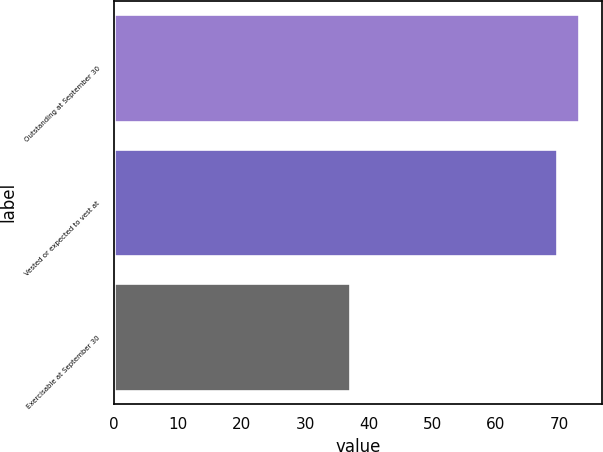Convert chart. <chart><loc_0><loc_0><loc_500><loc_500><bar_chart><fcel>Outstanding at September 30<fcel>Vested or expected to vest at<fcel>Exercisable at September 30<nl><fcel>73.14<fcel>69.6<fcel>37<nl></chart> 